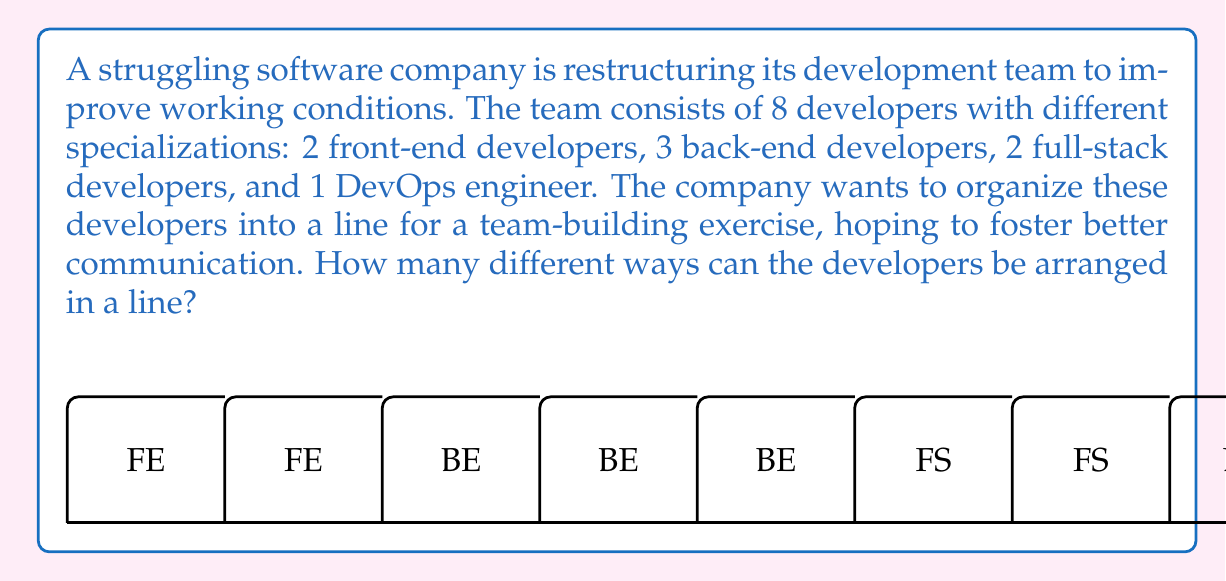Can you answer this question? To solve this problem, we need to use the concept of permutations. Since we are arranging all 8 developers in a line, and the order matters, this is a straightforward permutation problem.

Let's break it down step-by-step:

1) First, recall the formula for permutations of n distinct objects:

   $$P(n) = n!$$

   Where $n!$ represents the factorial of n.

2) In this case, we have 8 developers in total, so $n = 8$.

3) However, we need to consider that some developers have the same specialization. This creates repeated permutations that we need to account for:
   - 2 front-end developers (FE)
   - 3 back-end developers (BE)
   - 2 full-stack developers (FS)
   - 1 DevOps engineer (DO)

4) To handle this, we need to divide the total number of permutations by the number of permutations of each repeated group. This gives us the formula:

   $$\text{Number of unique permutations} = \frac{8!}{2! \times 3! \times 2! \times 1!}$$

5) Let's calculate this:
   
   $$\begin{align}
   &= \frac{8 \times 7 \times 6 \times 5 \times 4 \times 3 \times 2 \times 1}{(2 \times 1) \times (3 \times 2 \times 1) \times (2 \times 1) \times 1} \\
   &= \frac{40,320}{12 \times 6} \\
   &= \frac{40,320}{72} \\
   &= 560
   \end{align}$$

Therefore, there are 560 different ways to arrange the developers in a line.
Answer: 560 